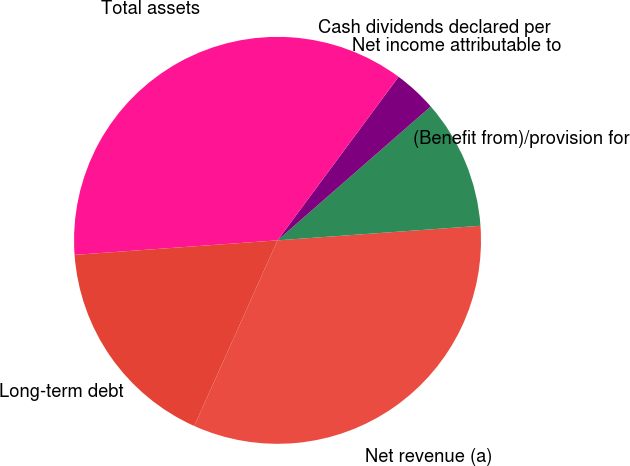<chart> <loc_0><loc_0><loc_500><loc_500><pie_chart><fcel>Net revenue (a)<fcel>(Benefit from)/provision for<fcel>Net income attributable to<fcel>Cash dividends declared per<fcel>Total assets<fcel>Long-term debt<nl><fcel>32.85%<fcel>10.29%<fcel>3.43%<fcel>0.0%<fcel>36.28%<fcel>17.15%<nl></chart> 